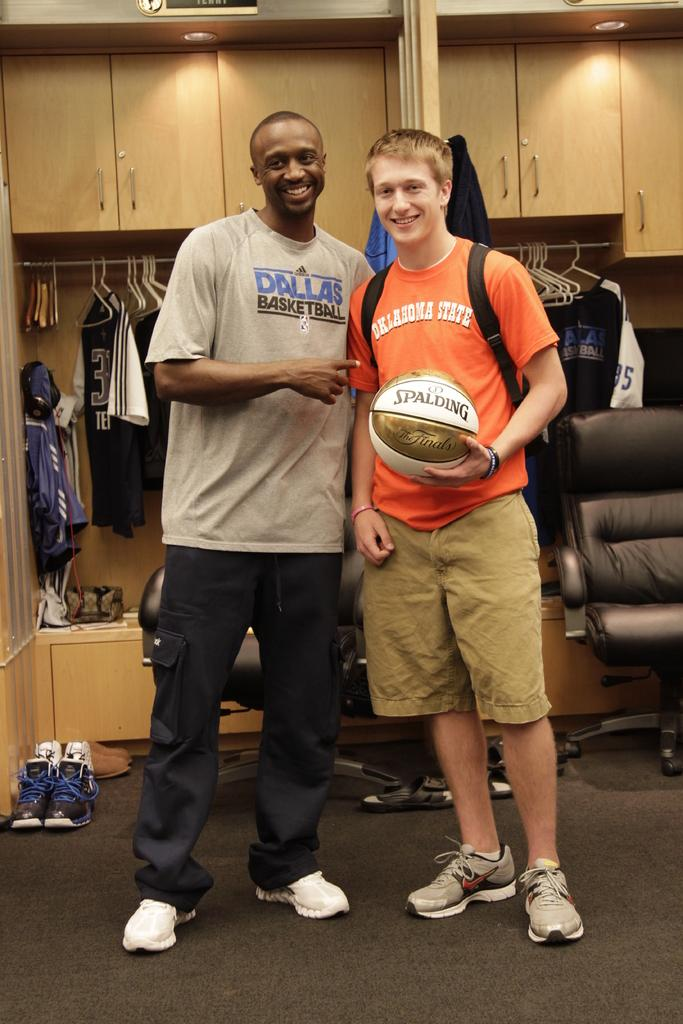<image>
Share a concise interpretation of the image provided. A black man with Dallas Basketball on his shirt is standing next to a white boy with red hair and Oklahoma State on his shirt. 